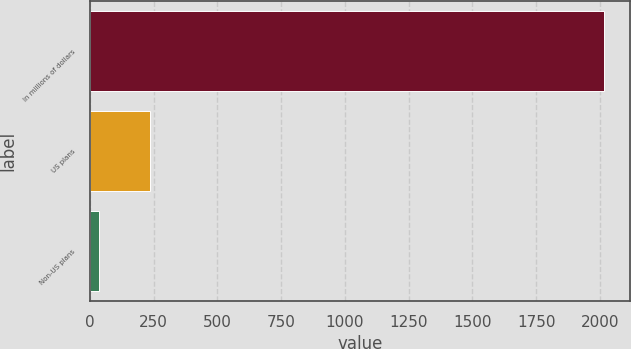Convert chart to OTSL. <chart><loc_0><loc_0><loc_500><loc_500><bar_chart><fcel>In millions of dollars<fcel>US plans<fcel>Non-US plans<nl><fcel>2016<fcel>234.9<fcel>37<nl></chart> 